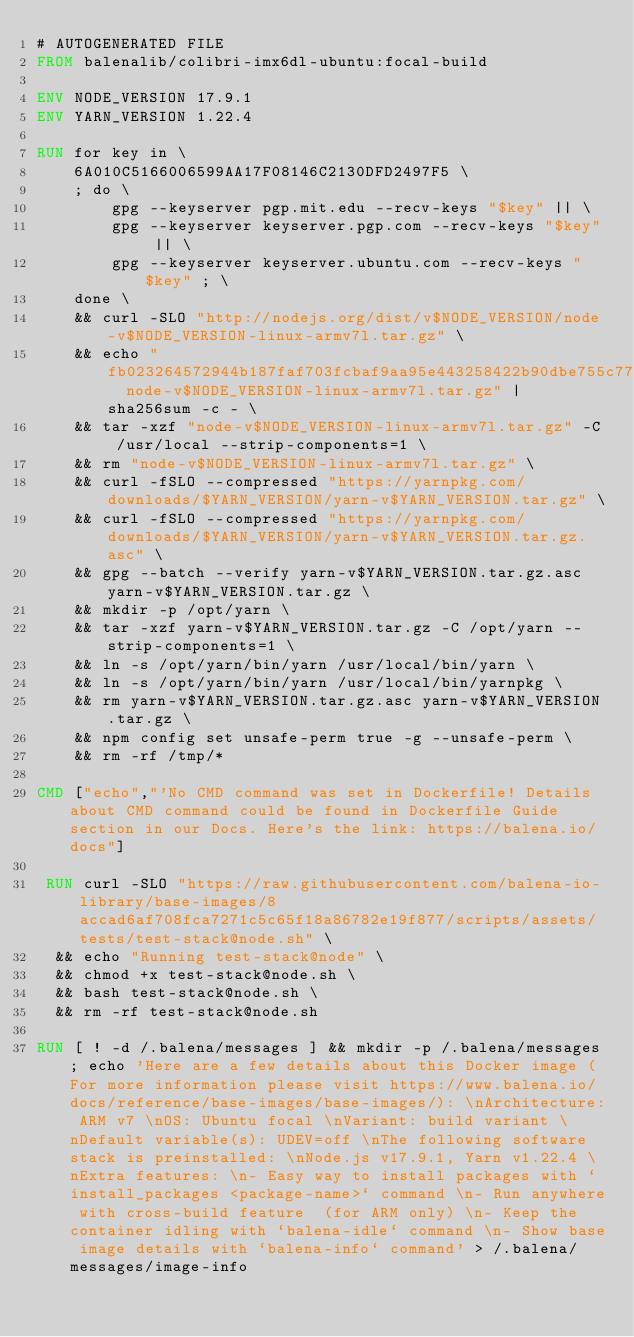Convert code to text. <code><loc_0><loc_0><loc_500><loc_500><_Dockerfile_># AUTOGENERATED FILE
FROM balenalib/colibri-imx6dl-ubuntu:focal-build

ENV NODE_VERSION 17.9.1
ENV YARN_VERSION 1.22.4

RUN for key in \
	6A010C5166006599AA17F08146C2130DFD2497F5 \
	; do \
		gpg --keyserver pgp.mit.edu --recv-keys "$key" || \
		gpg --keyserver keyserver.pgp.com --recv-keys "$key" || \
		gpg --keyserver keyserver.ubuntu.com --recv-keys "$key" ; \
	done \
	&& curl -SLO "http://nodejs.org/dist/v$NODE_VERSION/node-v$NODE_VERSION-linux-armv7l.tar.gz" \
	&& echo "fb023264572944b187faf703fcbaf9aa95e443258422b90dbe755c77d3082e0f  node-v$NODE_VERSION-linux-armv7l.tar.gz" | sha256sum -c - \
	&& tar -xzf "node-v$NODE_VERSION-linux-armv7l.tar.gz" -C /usr/local --strip-components=1 \
	&& rm "node-v$NODE_VERSION-linux-armv7l.tar.gz" \
	&& curl -fSLO --compressed "https://yarnpkg.com/downloads/$YARN_VERSION/yarn-v$YARN_VERSION.tar.gz" \
	&& curl -fSLO --compressed "https://yarnpkg.com/downloads/$YARN_VERSION/yarn-v$YARN_VERSION.tar.gz.asc" \
	&& gpg --batch --verify yarn-v$YARN_VERSION.tar.gz.asc yarn-v$YARN_VERSION.tar.gz \
	&& mkdir -p /opt/yarn \
	&& tar -xzf yarn-v$YARN_VERSION.tar.gz -C /opt/yarn --strip-components=1 \
	&& ln -s /opt/yarn/bin/yarn /usr/local/bin/yarn \
	&& ln -s /opt/yarn/bin/yarn /usr/local/bin/yarnpkg \
	&& rm yarn-v$YARN_VERSION.tar.gz.asc yarn-v$YARN_VERSION.tar.gz \
	&& npm config set unsafe-perm true -g --unsafe-perm \
	&& rm -rf /tmp/*

CMD ["echo","'No CMD command was set in Dockerfile! Details about CMD command could be found in Dockerfile Guide section in our Docs. Here's the link: https://balena.io/docs"]

 RUN curl -SLO "https://raw.githubusercontent.com/balena-io-library/base-images/8accad6af708fca7271c5c65f18a86782e19f877/scripts/assets/tests/test-stack@node.sh" \
  && echo "Running test-stack@node" \
  && chmod +x test-stack@node.sh \
  && bash test-stack@node.sh \
  && rm -rf test-stack@node.sh 

RUN [ ! -d /.balena/messages ] && mkdir -p /.balena/messages; echo 'Here are a few details about this Docker image (For more information please visit https://www.balena.io/docs/reference/base-images/base-images/): \nArchitecture: ARM v7 \nOS: Ubuntu focal \nVariant: build variant \nDefault variable(s): UDEV=off \nThe following software stack is preinstalled: \nNode.js v17.9.1, Yarn v1.22.4 \nExtra features: \n- Easy way to install packages with `install_packages <package-name>` command \n- Run anywhere with cross-build feature  (for ARM only) \n- Keep the container idling with `balena-idle` command \n- Show base image details with `balena-info` command' > /.balena/messages/image-info</code> 